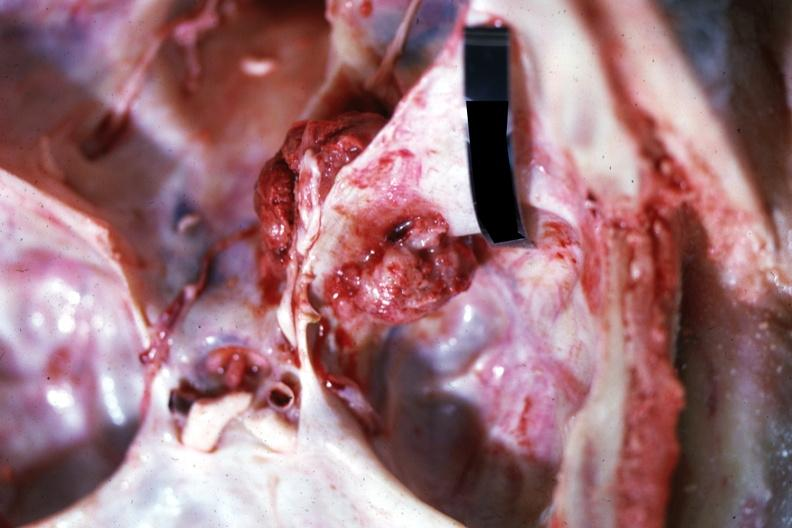s metastatic carcinoma present?
Answer the question using a single word or phrase. Yes 